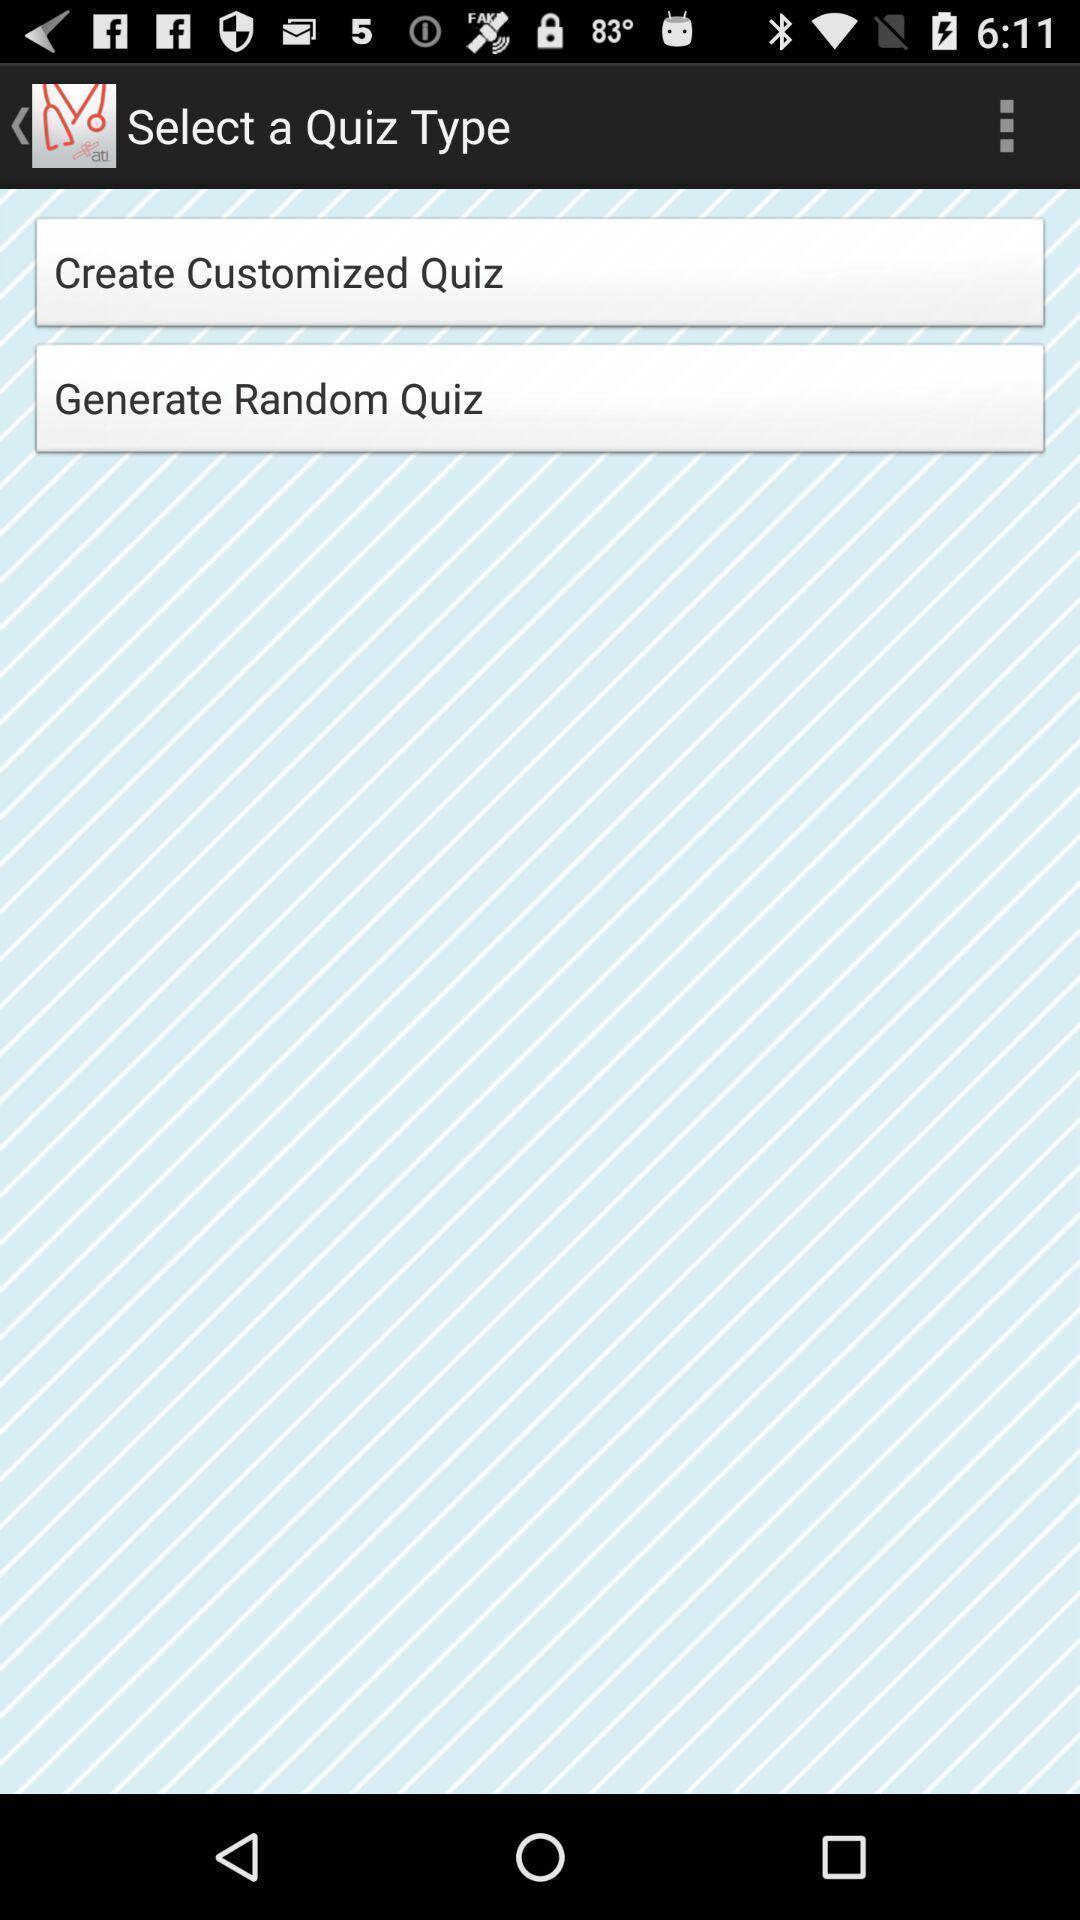Give me a summary of this screen capture. Page that displaying to select quiz type. 